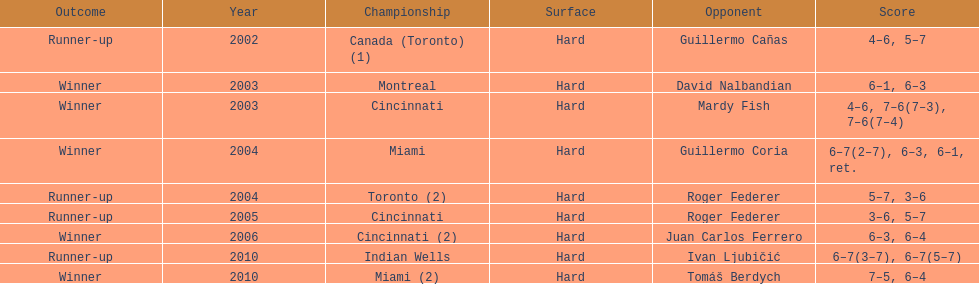Did roddick have more runner-up finishes or victories? Winner. 